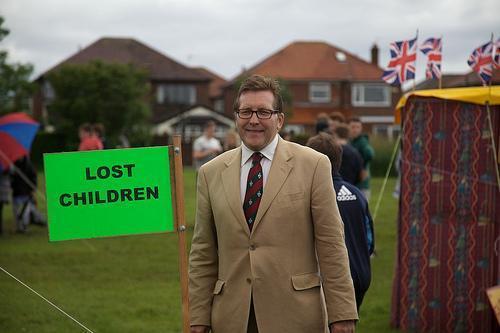How many signs are there?
Give a very brief answer. 1. 